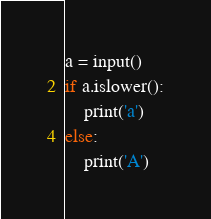<code> <loc_0><loc_0><loc_500><loc_500><_Python_>a = input()
if a.islower():
    print('a')
else:
    print('A')</code> 